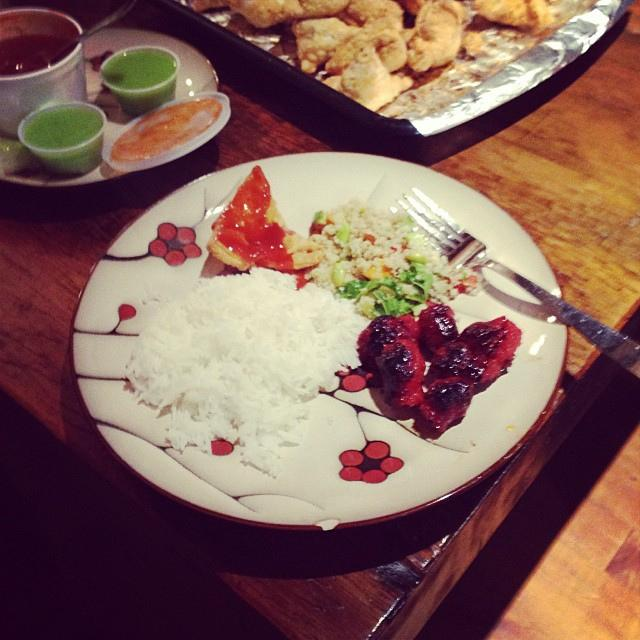How many of the ingredients on the dish were cooked by steaming them? one 